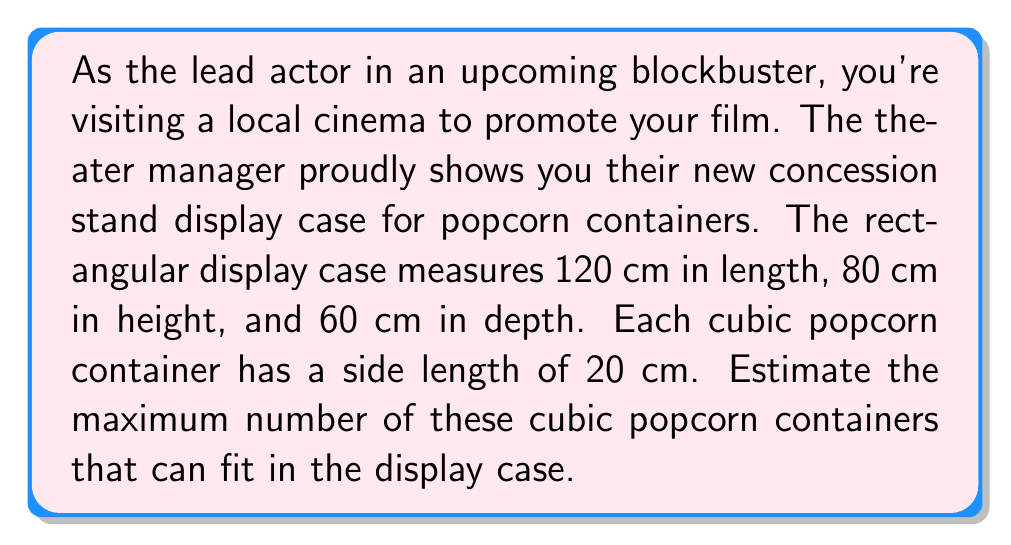Provide a solution to this math problem. To solve this problem, we need to follow these steps:

1. Calculate the volume of the rectangular display case:
   $$V_{case} = l \times w \times h$$
   $$V_{case} = 120 \text{ cm} \times 60 \text{ cm} \times 80 \text{ cm} = 576,000 \text{ cm}^3$$

2. Calculate the volume of one cubic popcorn container:
   $$V_{container} = s^3$$
   $$V_{container} = (20 \text{ cm})^3 = 8,000 \text{ cm}^3$$

3. Divide the volume of the display case by the volume of one container:
   $$N = \frac{V_{case}}{V_{container}} = \frac{576,000 \text{ cm}^3}{8,000 \text{ cm}^3} = 72$$

However, this calculation assumes perfect packing, which may not be possible due to the dimensions of the case and containers. We need to check how many containers can fit along each dimension:

4. Check the number of containers that can fit along each dimension:
   - Length: $120 \text{ cm} \div 20 \text{ cm} = 6$ containers
   - Width: $60 \text{ cm} \div 20 \text{ cm} = 3$ containers
   - Height: $80 \text{ cm} \div 20 \text{ cm} = 4$ containers

5. Calculate the actual number of containers that can fit:
   $$N_{actual} = 6 \times 3 \times 4 = 72$$

In this case, the estimated number from step 3 matches the actual number that can fit perfectly in the display case.

[asy]
import three;

size(200);
currentprojection=perspective(6,3,2);

draw(box((0,0,0),(6,3,4)),blue);

for(int i=0; i<6; ++i)
  for(int j=0; j<3; ++j)
    for(int k=0; k<4; ++k)
      draw(shift(i,j,k)*unitcube,red+opacity(0.1));

label("120 cm",(-0.5,1.5,0),W);
label("60 cm",(3,-0.5,0),S);
label("80 cm",(6,3,2),E);
[/asy]
Answer: The maximum number of cubic popcorn containers (20 cm side length) that can fit in the rectangular display case (120 cm × 60 cm × 80 cm) is 72. 